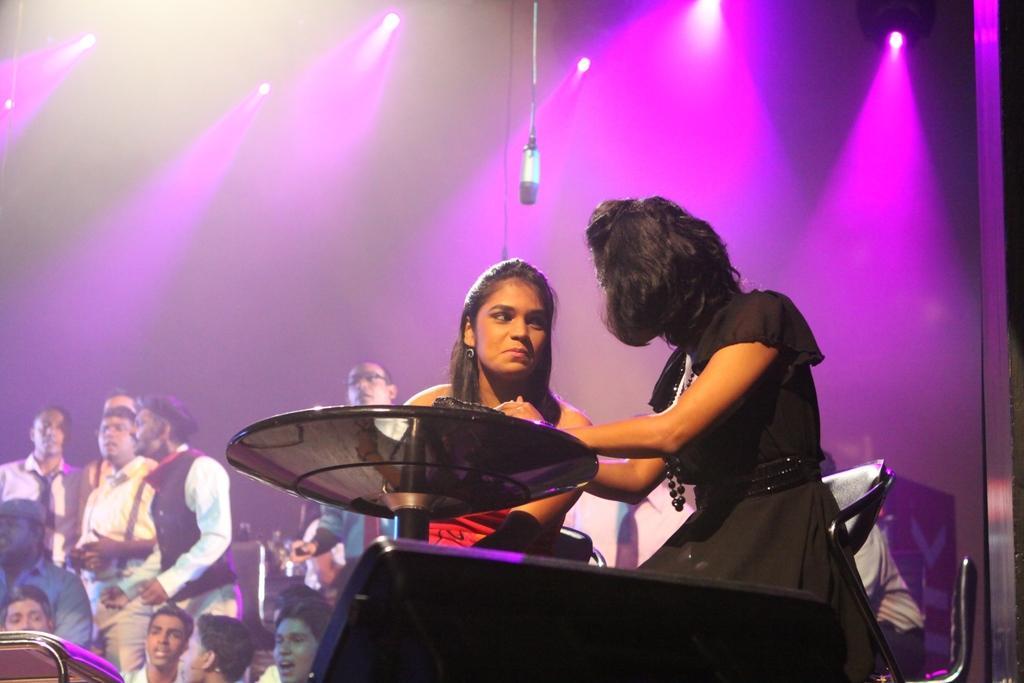Describe this image in one or two sentences. In the center of the image we can see two girls sitting on the chairs at the table. In the background we can see group of persons. In the background we can see lights. At the top of the image there is mic. 